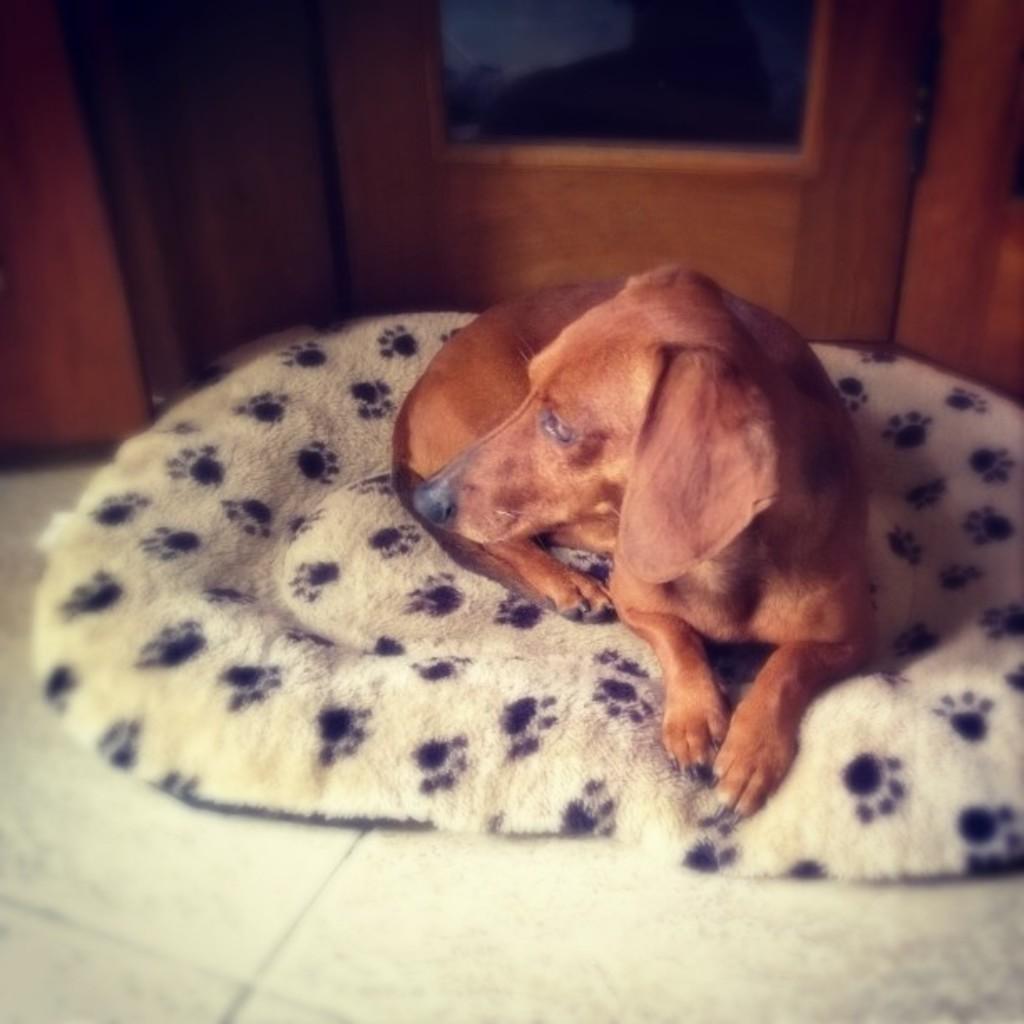How would you summarize this image in a sentence or two? In this picture we can see a dog on a dog bed, this dog bed is placed on a floor and in the background we can see some wooden objects. 